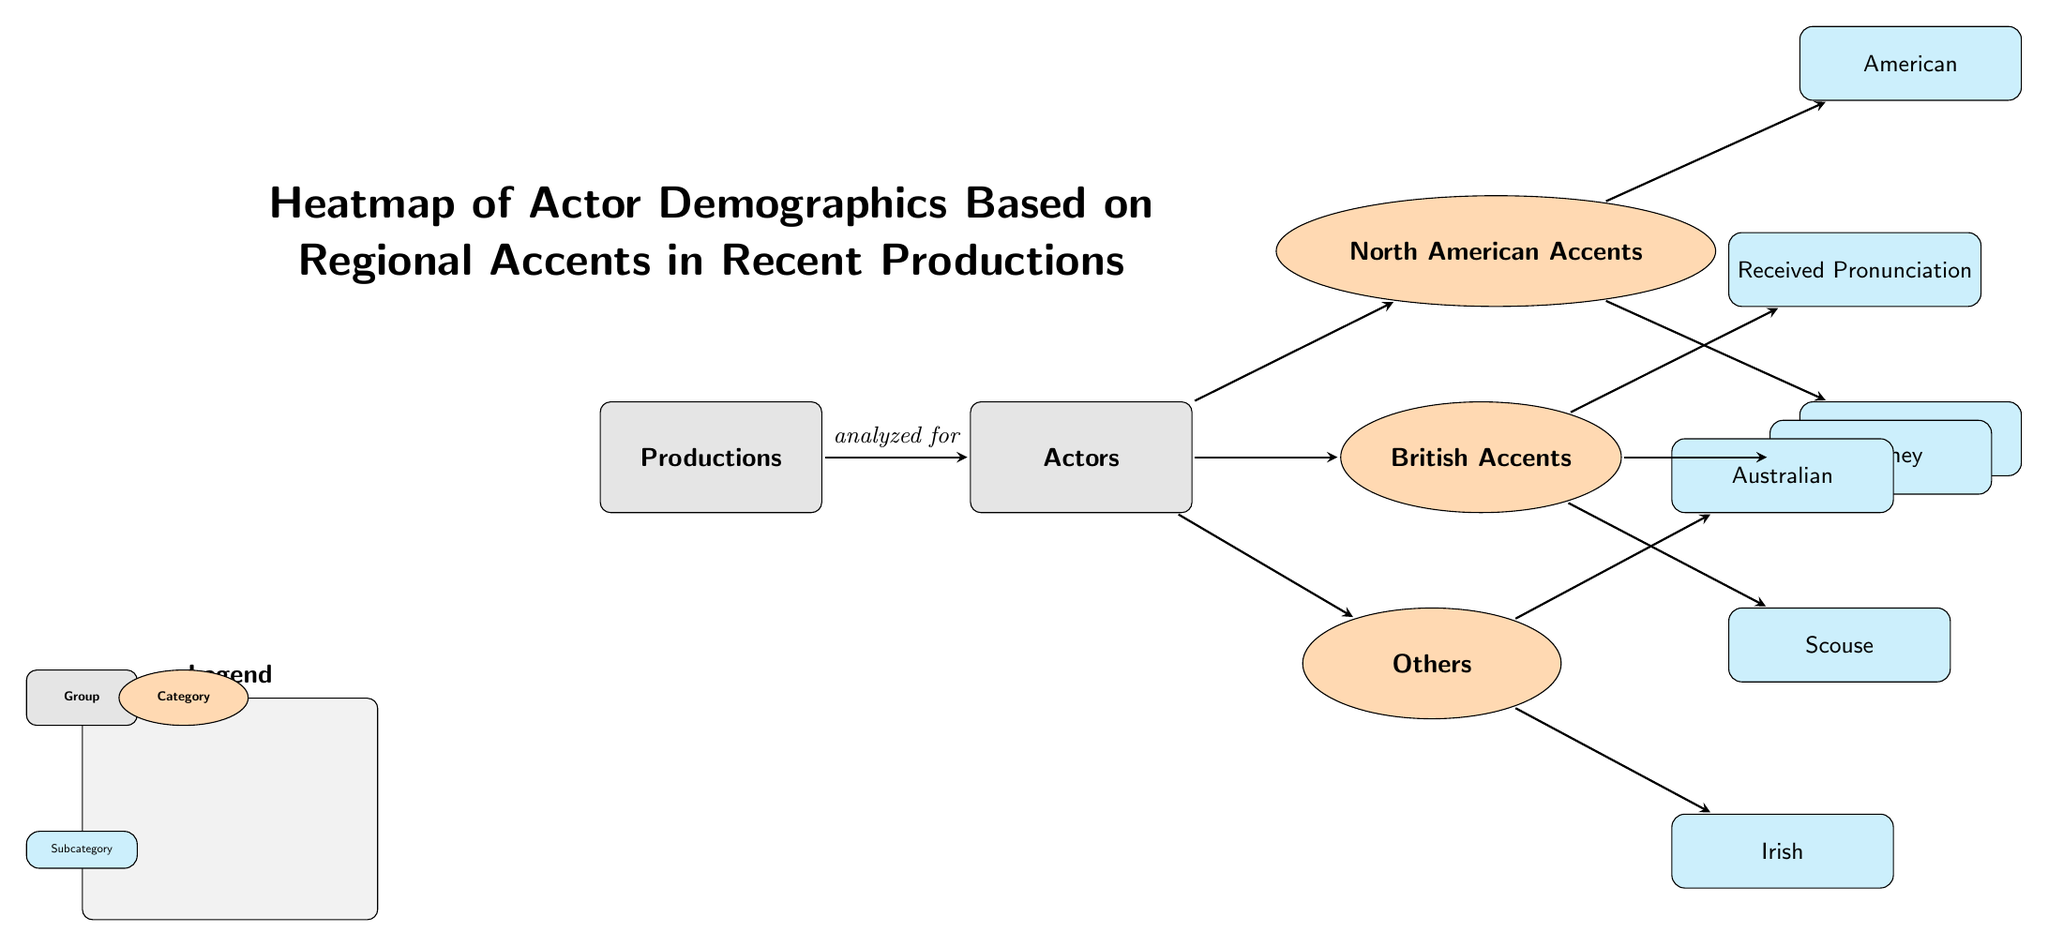What are the main groups displayed in the diagram? The diagram contains two main groups: Productions and Actors, as indicated by the rectangle shapes labeled with these titles.
Answer: Productions, Actors How many subcategories are listed under British Accents? The British Accents category has three subcategories listed: Received Pronunciation, Cockney, and Scouse.
Answer: Three Which accent category does Canadian belong to? The Canadian subcategory is a part of the North American Accents category, as it is positioned below the North American Accents node.
Answer: North American Accents What is the relationship between Actors and Productions in the diagram? The diagram shows that the Actors group is analyzed for insights from the Productions group, as represented by the directed arrow between the two.
Answer: Analyzed for List one accent under the Others category. Among the two subcategories listed under Others, one is Australian, which can be directly identified from the diagram.
Answer: Australian How many total accents are represented in the diagram? The diagram lists a total of seven accents, which are: American, Canadian, Received Pronunciation, Cockney, Scouse, Australian, and Irish.
Answer: Seven Which two accents fall under the North American Accents category? The diagram identifies American and Canadian as the two subcategories listed under the North American Accents category.
Answer: American, Canadian Which type of accent is represented by Received Pronunciation? Received Pronunciation is categorized under British Accents according to the structure of the diagram, showing its association with that category.
Answer: British Accents 